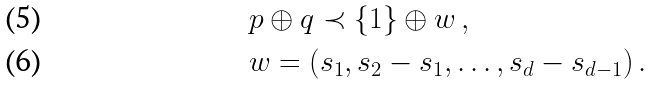Convert formula to latex. <formula><loc_0><loc_0><loc_500><loc_500>& p \oplus { q } \prec \{ 1 \} \oplus { w } \, , \\ & w = ( s _ { 1 } , s _ { 2 } - s _ { 1 } , \dots , s _ { d } - s _ { d - 1 } ) \, .</formula> 